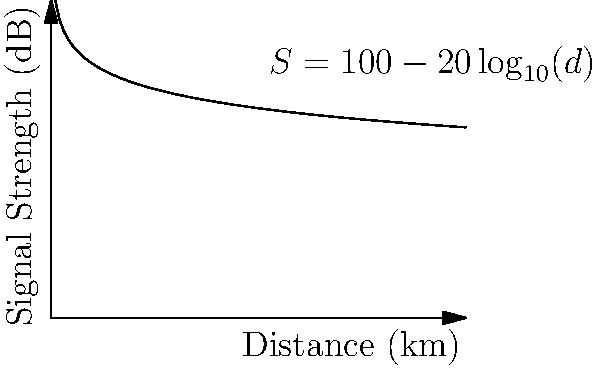A new satellite communication system uses a signal strength model described by the equation $S = 100 - 20\log_{10}(d)$, where $S$ is the signal strength in decibels (dB) and $d$ is the distance from the transmitter in kilometers. At what distance will the signal strength drop to 40 dB? To solve this problem, we need to use the given equation and solve for $d$ when $S = 40$ dB.

1) Start with the equation: $S = 100 - 20\log_{10}(d)$

2) Substitute $S = 40$:
   $40 = 100 - 20\log_{10}(d)$

3) Subtract 100 from both sides:
   $-60 = -20\log_{10}(d)$

4) Divide both sides by -20:
   $3 = \log_{10}(d)$

5) Apply $10^x$ to both sides to isolate $d$:
   $10^3 = 10^{\log_{10}(d)}$

6) Simplify:
   $1000 = d$

Therefore, the signal strength will drop to 40 dB at a distance of 1000 km from the transmitter.
Answer: 1000 km 